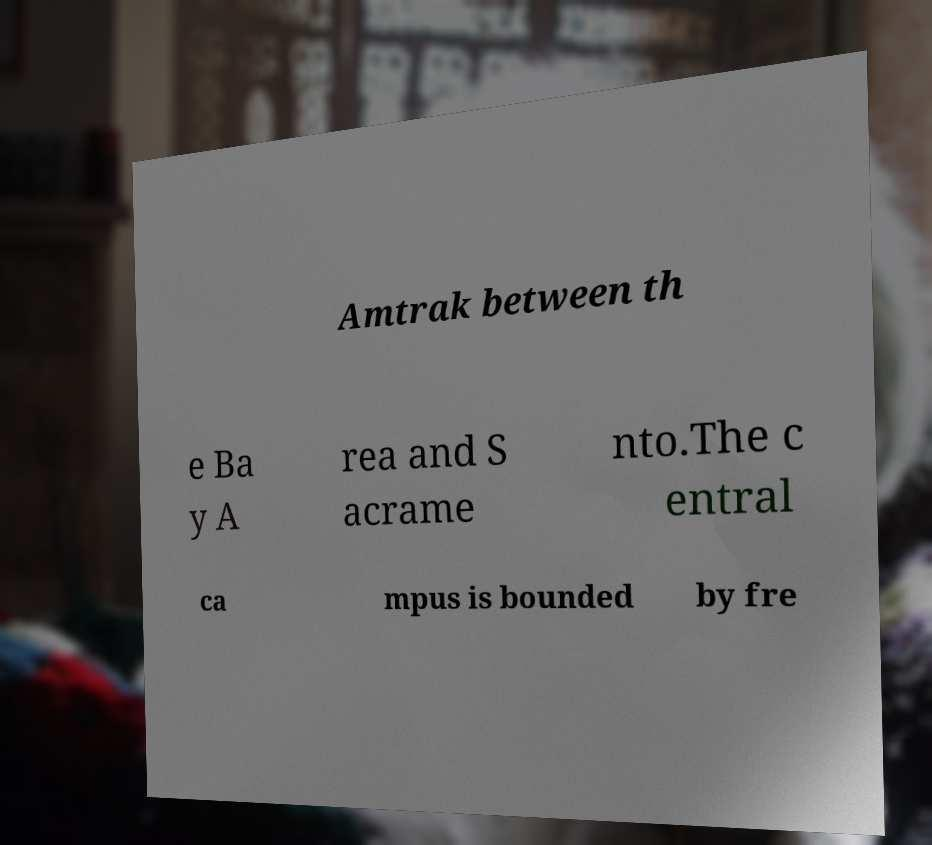Please identify and transcribe the text found in this image. Amtrak between th e Ba y A rea and S acrame nto.The c entral ca mpus is bounded by fre 